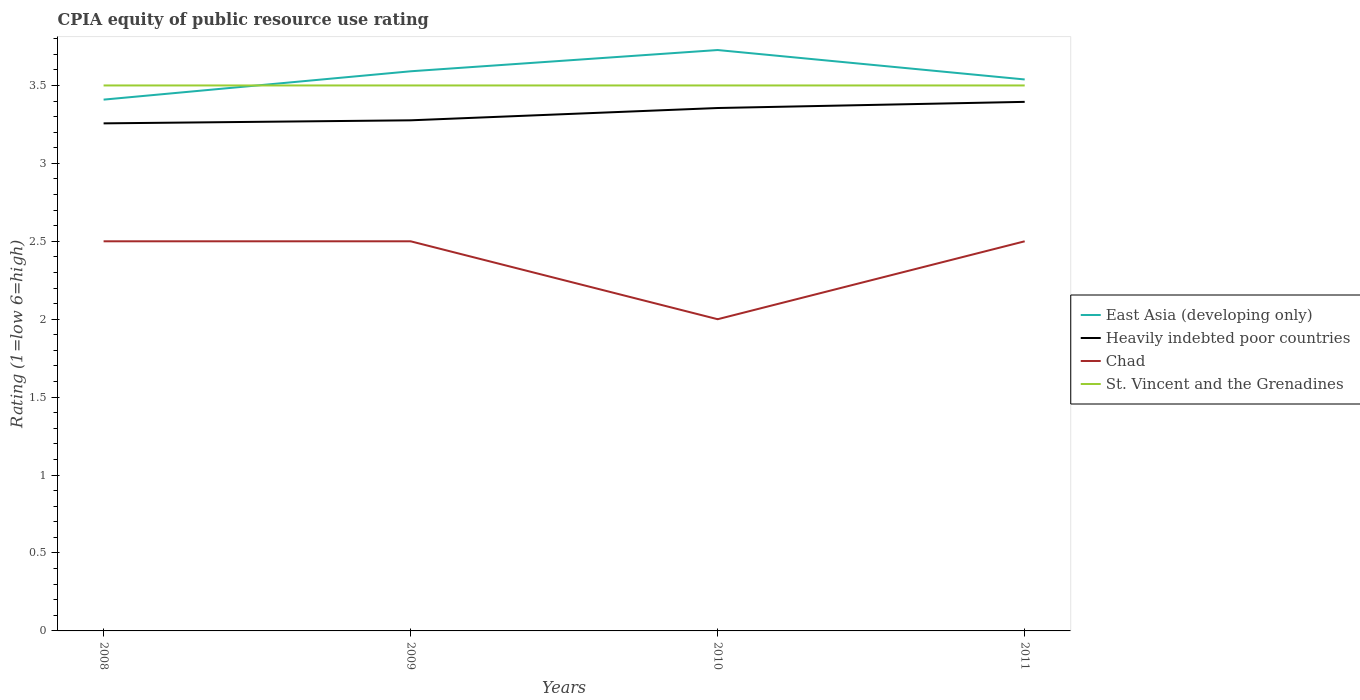Is the number of lines equal to the number of legend labels?
Your answer should be very brief. Yes. Across all years, what is the maximum CPIA rating in Heavily indebted poor countries?
Your answer should be compact. 3.26. In which year was the CPIA rating in Chad maximum?
Give a very brief answer. 2010. What is the total CPIA rating in East Asia (developing only) in the graph?
Keep it short and to the point. 0.05. What is the difference between the highest and the second highest CPIA rating in East Asia (developing only)?
Keep it short and to the point. 0.32. Is the CPIA rating in Chad strictly greater than the CPIA rating in Heavily indebted poor countries over the years?
Your response must be concise. Yes. Where does the legend appear in the graph?
Ensure brevity in your answer.  Center right. How many legend labels are there?
Keep it short and to the point. 4. What is the title of the graph?
Your answer should be very brief. CPIA equity of public resource use rating. What is the label or title of the Y-axis?
Your answer should be very brief. Rating (1=low 6=high). What is the Rating (1=low 6=high) of East Asia (developing only) in 2008?
Provide a succinct answer. 3.41. What is the Rating (1=low 6=high) in Heavily indebted poor countries in 2008?
Ensure brevity in your answer.  3.26. What is the Rating (1=low 6=high) in Chad in 2008?
Ensure brevity in your answer.  2.5. What is the Rating (1=low 6=high) in East Asia (developing only) in 2009?
Keep it short and to the point. 3.59. What is the Rating (1=low 6=high) in Heavily indebted poor countries in 2009?
Provide a succinct answer. 3.28. What is the Rating (1=low 6=high) of Chad in 2009?
Your answer should be very brief. 2.5. What is the Rating (1=low 6=high) of East Asia (developing only) in 2010?
Give a very brief answer. 3.73. What is the Rating (1=low 6=high) of Heavily indebted poor countries in 2010?
Provide a short and direct response. 3.36. What is the Rating (1=low 6=high) of St. Vincent and the Grenadines in 2010?
Give a very brief answer. 3.5. What is the Rating (1=low 6=high) of East Asia (developing only) in 2011?
Give a very brief answer. 3.54. What is the Rating (1=low 6=high) of Heavily indebted poor countries in 2011?
Provide a succinct answer. 3.39. What is the Rating (1=low 6=high) of Chad in 2011?
Offer a terse response. 2.5. What is the Rating (1=low 6=high) of St. Vincent and the Grenadines in 2011?
Provide a succinct answer. 3.5. Across all years, what is the maximum Rating (1=low 6=high) in East Asia (developing only)?
Offer a very short reply. 3.73. Across all years, what is the maximum Rating (1=low 6=high) in Heavily indebted poor countries?
Your answer should be compact. 3.39. Across all years, what is the minimum Rating (1=low 6=high) of East Asia (developing only)?
Give a very brief answer. 3.41. Across all years, what is the minimum Rating (1=low 6=high) of Heavily indebted poor countries?
Provide a succinct answer. 3.26. Across all years, what is the minimum Rating (1=low 6=high) of St. Vincent and the Grenadines?
Ensure brevity in your answer.  3.5. What is the total Rating (1=low 6=high) in East Asia (developing only) in the graph?
Provide a succinct answer. 14.27. What is the total Rating (1=low 6=high) in Heavily indebted poor countries in the graph?
Your answer should be very brief. 13.28. What is the total Rating (1=low 6=high) in Chad in the graph?
Offer a very short reply. 9.5. What is the total Rating (1=low 6=high) of St. Vincent and the Grenadines in the graph?
Offer a terse response. 14. What is the difference between the Rating (1=low 6=high) of East Asia (developing only) in 2008 and that in 2009?
Keep it short and to the point. -0.18. What is the difference between the Rating (1=low 6=high) of Heavily indebted poor countries in 2008 and that in 2009?
Give a very brief answer. -0.02. What is the difference between the Rating (1=low 6=high) in Chad in 2008 and that in 2009?
Offer a very short reply. 0. What is the difference between the Rating (1=low 6=high) of St. Vincent and the Grenadines in 2008 and that in 2009?
Ensure brevity in your answer.  0. What is the difference between the Rating (1=low 6=high) in East Asia (developing only) in 2008 and that in 2010?
Offer a terse response. -0.32. What is the difference between the Rating (1=low 6=high) of Heavily indebted poor countries in 2008 and that in 2010?
Make the answer very short. -0.1. What is the difference between the Rating (1=low 6=high) in East Asia (developing only) in 2008 and that in 2011?
Provide a short and direct response. -0.13. What is the difference between the Rating (1=low 6=high) in Heavily indebted poor countries in 2008 and that in 2011?
Offer a terse response. -0.14. What is the difference between the Rating (1=low 6=high) of St. Vincent and the Grenadines in 2008 and that in 2011?
Keep it short and to the point. 0. What is the difference between the Rating (1=low 6=high) of East Asia (developing only) in 2009 and that in 2010?
Your response must be concise. -0.14. What is the difference between the Rating (1=low 6=high) in Heavily indebted poor countries in 2009 and that in 2010?
Make the answer very short. -0.08. What is the difference between the Rating (1=low 6=high) in Chad in 2009 and that in 2010?
Offer a terse response. 0.5. What is the difference between the Rating (1=low 6=high) in East Asia (developing only) in 2009 and that in 2011?
Provide a succinct answer. 0.05. What is the difference between the Rating (1=low 6=high) in Heavily indebted poor countries in 2009 and that in 2011?
Offer a terse response. -0.12. What is the difference between the Rating (1=low 6=high) of Chad in 2009 and that in 2011?
Offer a very short reply. 0. What is the difference between the Rating (1=low 6=high) of East Asia (developing only) in 2010 and that in 2011?
Provide a short and direct response. 0.19. What is the difference between the Rating (1=low 6=high) in Heavily indebted poor countries in 2010 and that in 2011?
Ensure brevity in your answer.  -0.04. What is the difference between the Rating (1=low 6=high) in East Asia (developing only) in 2008 and the Rating (1=low 6=high) in Heavily indebted poor countries in 2009?
Your answer should be compact. 0.13. What is the difference between the Rating (1=low 6=high) in East Asia (developing only) in 2008 and the Rating (1=low 6=high) in St. Vincent and the Grenadines in 2009?
Your answer should be very brief. -0.09. What is the difference between the Rating (1=low 6=high) of Heavily indebted poor countries in 2008 and the Rating (1=low 6=high) of Chad in 2009?
Give a very brief answer. 0.76. What is the difference between the Rating (1=low 6=high) in Heavily indebted poor countries in 2008 and the Rating (1=low 6=high) in St. Vincent and the Grenadines in 2009?
Keep it short and to the point. -0.24. What is the difference between the Rating (1=low 6=high) of East Asia (developing only) in 2008 and the Rating (1=low 6=high) of Heavily indebted poor countries in 2010?
Your answer should be compact. 0.05. What is the difference between the Rating (1=low 6=high) in East Asia (developing only) in 2008 and the Rating (1=low 6=high) in Chad in 2010?
Ensure brevity in your answer.  1.41. What is the difference between the Rating (1=low 6=high) of East Asia (developing only) in 2008 and the Rating (1=low 6=high) of St. Vincent and the Grenadines in 2010?
Offer a terse response. -0.09. What is the difference between the Rating (1=low 6=high) in Heavily indebted poor countries in 2008 and the Rating (1=low 6=high) in Chad in 2010?
Your answer should be very brief. 1.26. What is the difference between the Rating (1=low 6=high) of Heavily indebted poor countries in 2008 and the Rating (1=low 6=high) of St. Vincent and the Grenadines in 2010?
Your answer should be compact. -0.24. What is the difference between the Rating (1=low 6=high) of Chad in 2008 and the Rating (1=low 6=high) of St. Vincent and the Grenadines in 2010?
Your response must be concise. -1. What is the difference between the Rating (1=low 6=high) in East Asia (developing only) in 2008 and the Rating (1=low 6=high) in Heavily indebted poor countries in 2011?
Provide a succinct answer. 0.01. What is the difference between the Rating (1=low 6=high) of East Asia (developing only) in 2008 and the Rating (1=low 6=high) of St. Vincent and the Grenadines in 2011?
Your answer should be compact. -0.09. What is the difference between the Rating (1=low 6=high) of Heavily indebted poor countries in 2008 and the Rating (1=low 6=high) of Chad in 2011?
Offer a terse response. 0.76. What is the difference between the Rating (1=low 6=high) of Heavily indebted poor countries in 2008 and the Rating (1=low 6=high) of St. Vincent and the Grenadines in 2011?
Provide a short and direct response. -0.24. What is the difference between the Rating (1=low 6=high) in East Asia (developing only) in 2009 and the Rating (1=low 6=high) in Heavily indebted poor countries in 2010?
Give a very brief answer. 0.24. What is the difference between the Rating (1=low 6=high) of East Asia (developing only) in 2009 and the Rating (1=low 6=high) of Chad in 2010?
Ensure brevity in your answer.  1.59. What is the difference between the Rating (1=low 6=high) of East Asia (developing only) in 2009 and the Rating (1=low 6=high) of St. Vincent and the Grenadines in 2010?
Your answer should be compact. 0.09. What is the difference between the Rating (1=low 6=high) of Heavily indebted poor countries in 2009 and the Rating (1=low 6=high) of Chad in 2010?
Make the answer very short. 1.28. What is the difference between the Rating (1=low 6=high) in Heavily indebted poor countries in 2009 and the Rating (1=low 6=high) in St. Vincent and the Grenadines in 2010?
Offer a terse response. -0.22. What is the difference between the Rating (1=low 6=high) of Chad in 2009 and the Rating (1=low 6=high) of St. Vincent and the Grenadines in 2010?
Make the answer very short. -1. What is the difference between the Rating (1=low 6=high) in East Asia (developing only) in 2009 and the Rating (1=low 6=high) in Heavily indebted poor countries in 2011?
Give a very brief answer. 0.2. What is the difference between the Rating (1=low 6=high) in East Asia (developing only) in 2009 and the Rating (1=low 6=high) in St. Vincent and the Grenadines in 2011?
Give a very brief answer. 0.09. What is the difference between the Rating (1=low 6=high) of Heavily indebted poor countries in 2009 and the Rating (1=low 6=high) of Chad in 2011?
Your answer should be very brief. 0.78. What is the difference between the Rating (1=low 6=high) of Heavily indebted poor countries in 2009 and the Rating (1=low 6=high) of St. Vincent and the Grenadines in 2011?
Keep it short and to the point. -0.22. What is the difference between the Rating (1=low 6=high) in Chad in 2009 and the Rating (1=low 6=high) in St. Vincent and the Grenadines in 2011?
Make the answer very short. -1. What is the difference between the Rating (1=low 6=high) of East Asia (developing only) in 2010 and the Rating (1=low 6=high) of Heavily indebted poor countries in 2011?
Your response must be concise. 0.33. What is the difference between the Rating (1=low 6=high) of East Asia (developing only) in 2010 and the Rating (1=low 6=high) of Chad in 2011?
Your answer should be compact. 1.23. What is the difference between the Rating (1=low 6=high) of East Asia (developing only) in 2010 and the Rating (1=low 6=high) of St. Vincent and the Grenadines in 2011?
Keep it short and to the point. 0.23. What is the difference between the Rating (1=low 6=high) in Heavily indebted poor countries in 2010 and the Rating (1=low 6=high) in Chad in 2011?
Ensure brevity in your answer.  0.86. What is the difference between the Rating (1=low 6=high) in Heavily indebted poor countries in 2010 and the Rating (1=low 6=high) in St. Vincent and the Grenadines in 2011?
Offer a very short reply. -0.14. What is the difference between the Rating (1=low 6=high) in Chad in 2010 and the Rating (1=low 6=high) in St. Vincent and the Grenadines in 2011?
Provide a succinct answer. -1.5. What is the average Rating (1=low 6=high) of East Asia (developing only) per year?
Provide a short and direct response. 3.57. What is the average Rating (1=low 6=high) of Heavily indebted poor countries per year?
Your answer should be very brief. 3.32. What is the average Rating (1=low 6=high) of Chad per year?
Give a very brief answer. 2.38. What is the average Rating (1=low 6=high) in St. Vincent and the Grenadines per year?
Provide a short and direct response. 3.5. In the year 2008, what is the difference between the Rating (1=low 6=high) of East Asia (developing only) and Rating (1=low 6=high) of Heavily indebted poor countries?
Ensure brevity in your answer.  0.15. In the year 2008, what is the difference between the Rating (1=low 6=high) of East Asia (developing only) and Rating (1=low 6=high) of St. Vincent and the Grenadines?
Offer a very short reply. -0.09. In the year 2008, what is the difference between the Rating (1=low 6=high) of Heavily indebted poor countries and Rating (1=low 6=high) of Chad?
Offer a terse response. 0.76. In the year 2008, what is the difference between the Rating (1=low 6=high) in Heavily indebted poor countries and Rating (1=low 6=high) in St. Vincent and the Grenadines?
Make the answer very short. -0.24. In the year 2008, what is the difference between the Rating (1=low 6=high) in Chad and Rating (1=low 6=high) in St. Vincent and the Grenadines?
Your answer should be compact. -1. In the year 2009, what is the difference between the Rating (1=low 6=high) in East Asia (developing only) and Rating (1=low 6=high) in Heavily indebted poor countries?
Your answer should be compact. 0.31. In the year 2009, what is the difference between the Rating (1=low 6=high) in East Asia (developing only) and Rating (1=low 6=high) in Chad?
Give a very brief answer. 1.09. In the year 2009, what is the difference between the Rating (1=low 6=high) in East Asia (developing only) and Rating (1=low 6=high) in St. Vincent and the Grenadines?
Keep it short and to the point. 0.09. In the year 2009, what is the difference between the Rating (1=low 6=high) in Heavily indebted poor countries and Rating (1=low 6=high) in Chad?
Offer a very short reply. 0.78. In the year 2009, what is the difference between the Rating (1=low 6=high) of Heavily indebted poor countries and Rating (1=low 6=high) of St. Vincent and the Grenadines?
Your response must be concise. -0.22. In the year 2010, what is the difference between the Rating (1=low 6=high) of East Asia (developing only) and Rating (1=low 6=high) of Heavily indebted poor countries?
Keep it short and to the point. 0.37. In the year 2010, what is the difference between the Rating (1=low 6=high) in East Asia (developing only) and Rating (1=low 6=high) in Chad?
Your answer should be compact. 1.73. In the year 2010, what is the difference between the Rating (1=low 6=high) of East Asia (developing only) and Rating (1=low 6=high) of St. Vincent and the Grenadines?
Provide a short and direct response. 0.23. In the year 2010, what is the difference between the Rating (1=low 6=high) of Heavily indebted poor countries and Rating (1=low 6=high) of Chad?
Provide a succinct answer. 1.36. In the year 2010, what is the difference between the Rating (1=low 6=high) of Heavily indebted poor countries and Rating (1=low 6=high) of St. Vincent and the Grenadines?
Your answer should be compact. -0.14. In the year 2010, what is the difference between the Rating (1=low 6=high) in Chad and Rating (1=low 6=high) in St. Vincent and the Grenadines?
Offer a terse response. -1.5. In the year 2011, what is the difference between the Rating (1=low 6=high) of East Asia (developing only) and Rating (1=low 6=high) of Heavily indebted poor countries?
Your answer should be compact. 0.14. In the year 2011, what is the difference between the Rating (1=low 6=high) in East Asia (developing only) and Rating (1=low 6=high) in St. Vincent and the Grenadines?
Keep it short and to the point. 0.04. In the year 2011, what is the difference between the Rating (1=low 6=high) of Heavily indebted poor countries and Rating (1=low 6=high) of Chad?
Your answer should be compact. 0.89. In the year 2011, what is the difference between the Rating (1=low 6=high) of Heavily indebted poor countries and Rating (1=low 6=high) of St. Vincent and the Grenadines?
Provide a short and direct response. -0.11. In the year 2011, what is the difference between the Rating (1=low 6=high) in Chad and Rating (1=low 6=high) in St. Vincent and the Grenadines?
Offer a terse response. -1. What is the ratio of the Rating (1=low 6=high) in East Asia (developing only) in 2008 to that in 2009?
Offer a terse response. 0.95. What is the ratio of the Rating (1=low 6=high) in Chad in 2008 to that in 2009?
Make the answer very short. 1. What is the ratio of the Rating (1=low 6=high) of East Asia (developing only) in 2008 to that in 2010?
Give a very brief answer. 0.91. What is the ratio of the Rating (1=low 6=high) in Heavily indebted poor countries in 2008 to that in 2010?
Keep it short and to the point. 0.97. What is the ratio of the Rating (1=low 6=high) in East Asia (developing only) in 2008 to that in 2011?
Provide a short and direct response. 0.96. What is the ratio of the Rating (1=low 6=high) of Heavily indebted poor countries in 2008 to that in 2011?
Ensure brevity in your answer.  0.96. What is the ratio of the Rating (1=low 6=high) of Chad in 2008 to that in 2011?
Your answer should be very brief. 1. What is the ratio of the Rating (1=low 6=high) in East Asia (developing only) in 2009 to that in 2010?
Ensure brevity in your answer.  0.96. What is the ratio of the Rating (1=low 6=high) in Heavily indebted poor countries in 2009 to that in 2010?
Provide a succinct answer. 0.98. What is the ratio of the Rating (1=low 6=high) in Chad in 2009 to that in 2010?
Provide a succinct answer. 1.25. What is the ratio of the Rating (1=low 6=high) of East Asia (developing only) in 2009 to that in 2011?
Provide a short and direct response. 1.01. What is the ratio of the Rating (1=low 6=high) in Heavily indebted poor countries in 2009 to that in 2011?
Give a very brief answer. 0.97. What is the ratio of the Rating (1=low 6=high) of St. Vincent and the Grenadines in 2009 to that in 2011?
Make the answer very short. 1. What is the ratio of the Rating (1=low 6=high) in East Asia (developing only) in 2010 to that in 2011?
Make the answer very short. 1.05. What is the ratio of the Rating (1=low 6=high) in Heavily indebted poor countries in 2010 to that in 2011?
Your answer should be very brief. 0.99. What is the ratio of the Rating (1=low 6=high) of St. Vincent and the Grenadines in 2010 to that in 2011?
Keep it short and to the point. 1. What is the difference between the highest and the second highest Rating (1=low 6=high) of East Asia (developing only)?
Make the answer very short. 0.14. What is the difference between the highest and the second highest Rating (1=low 6=high) of Heavily indebted poor countries?
Give a very brief answer. 0.04. What is the difference between the highest and the second highest Rating (1=low 6=high) in Chad?
Offer a very short reply. 0. What is the difference between the highest and the lowest Rating (1=low 6=high) of East Asia (developing only)?
Provide a short and direct response. 0.32. What is the difference between the highest and the lowest Rating (1=low 6=high) of Heavily indebted poor countries?
Provide a short and direct response. 0.14. What is the difference between the highest and the lowest Rating (1=low 6=high) in Chad?
Provide a succinct answer. 0.5. What is the difference between the highest and the lowest Rating (1=low 6=high) in St. Vincent and the Grenadines?
Your response must be concise. 0. 